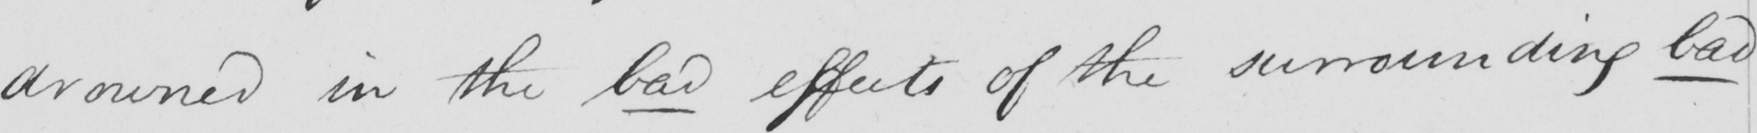What does this handwritten line say? drowned in the bad effects of the surrounding bad 